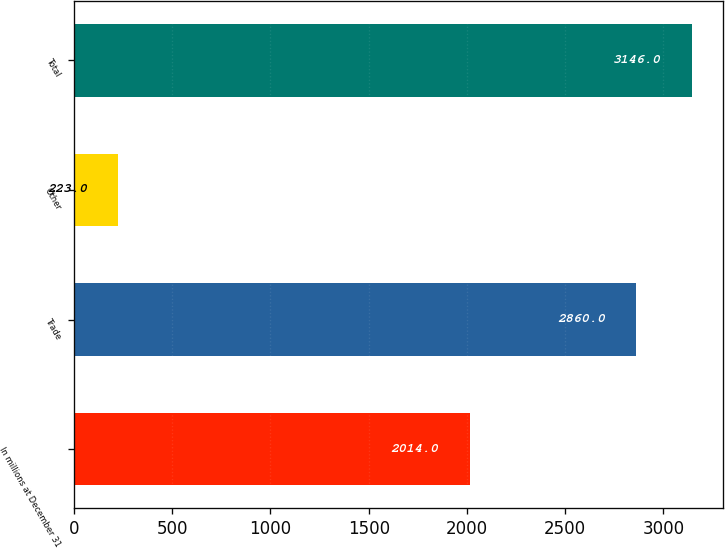Convert chart. <chart><loc_0><loc_0><loc_500><loc_500><bar_chart><fcel>In millions at December 31<fcel>Trade<fcel>Other<fcel>Total<nl><fcel>2014<fcel>2860<fcel>223<fcel>3146<nl></chart> 